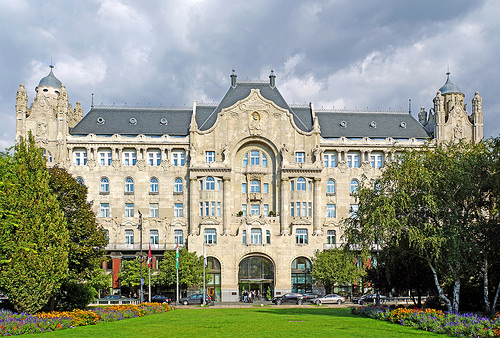<image>
Can you confirm if the car is behind the building? No. The car is not behind the building. From this viewpoint, the car appears to be positioned elsewhere in the scene. Is there a building next to the tree? No. The building is not positioned next to the tree. They are located in different areas of the scene. Is the mansion in front of the tree? No. The mansion is not in front of the tree. The spatial positioning shows a different relationship between these objects. 